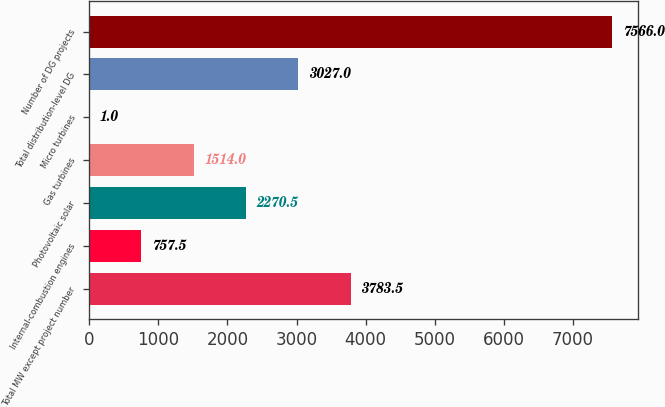Convert chart to OTSL. <chart><loc_0><loc_0><loc_500><loc_500><bar_chart><fcel>Total MW except project number<fcel>Internal-combustion engines<fcel>Photovoltaic solar<fcel>Gas turbines<fcel>Micro turbines<fcel>Total distribution-level DG<fcel>Number of DG projects<nl><fcel>3783.5<fcel>757.5<fcel>2270.5<fcel>1514<fcel>1<fcel>3027<fcel>7566<nl></chart> 